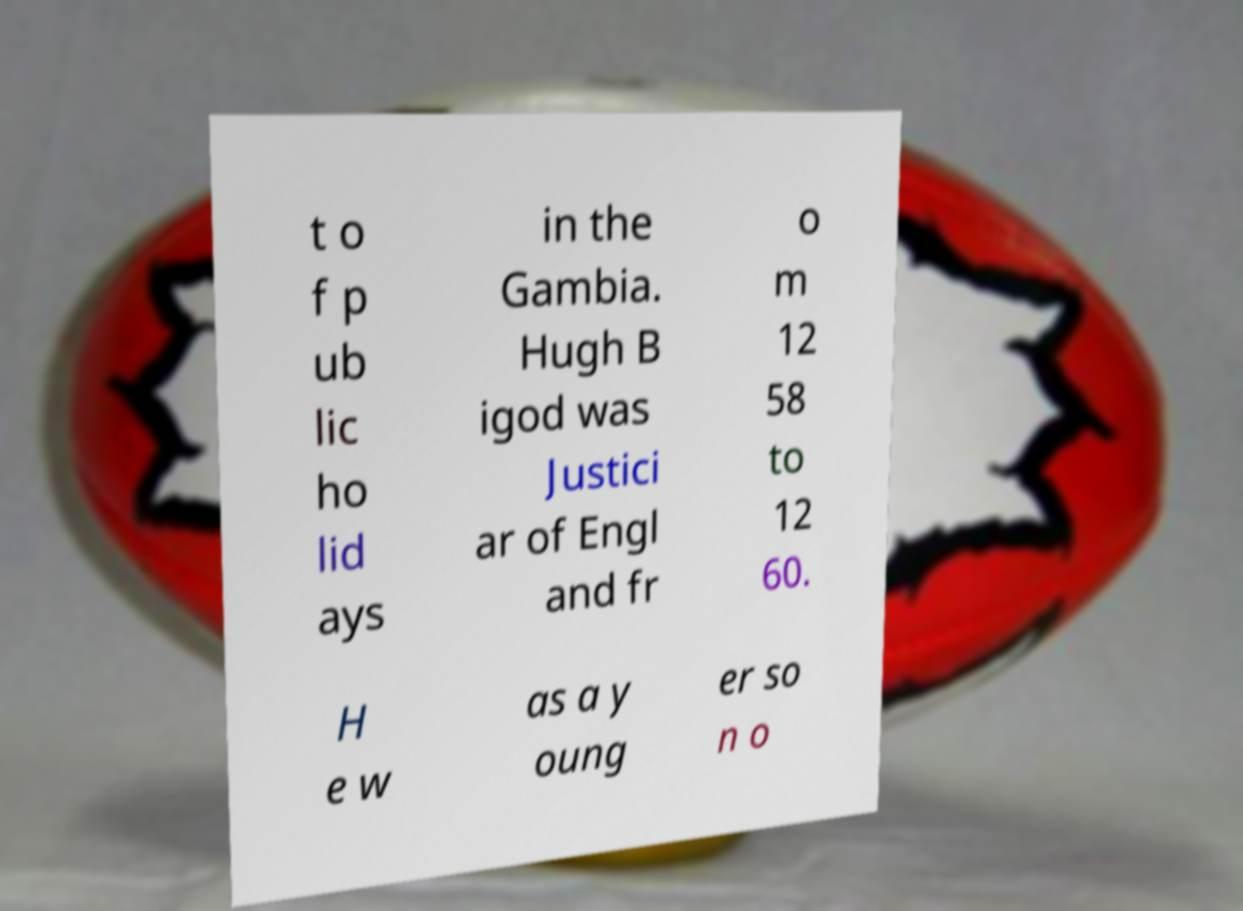Could you extract and type out the text from this image? t o f p ub lic ho lid ays in the Gambia. Hugh B igod was Justici ar of Engl and fr o m 12 58 to 12 60. H e w as a y oung er so n o 